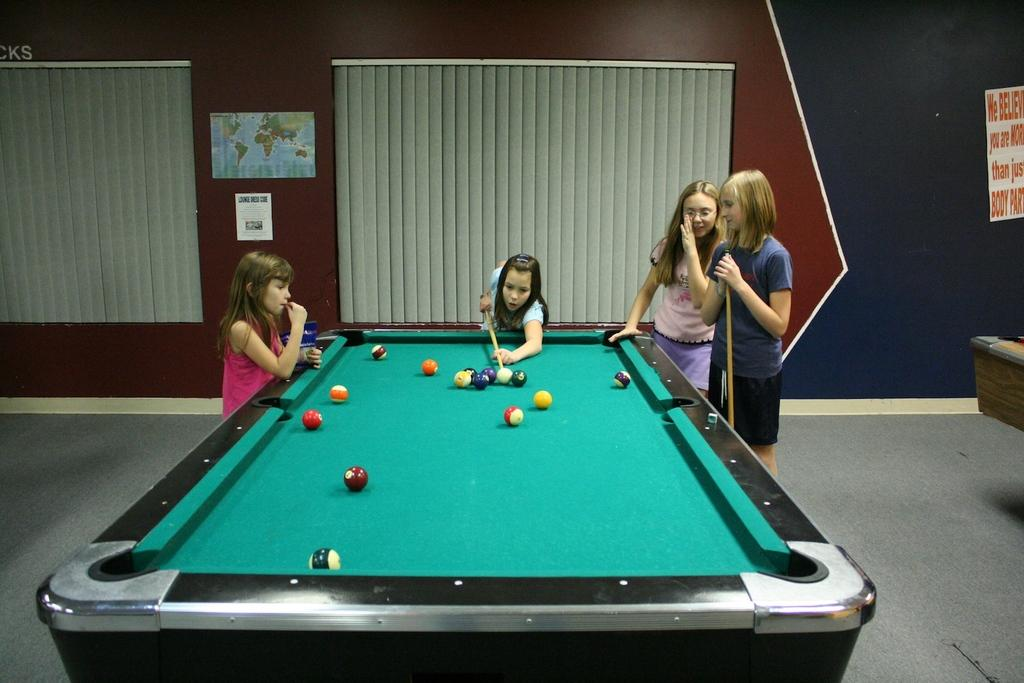What activity is the girl in the image engaged in? There is a girl playing snooker in the image. How many girls are standing in the image? There are two girls standing on the right side of the image and one girl standing on the left side of the image. What type of can is visible on the snooker table in the image? There is no can visible on the snooker table in the image. How many arms does the girl playing snooker have in the image? The girl playing snooker has two arms, as is typical for humans. What unit of measurement is used to determine the length of the snooker table in the image? The image does not provide information about the length of the snooker table or the unit of measurement used. 